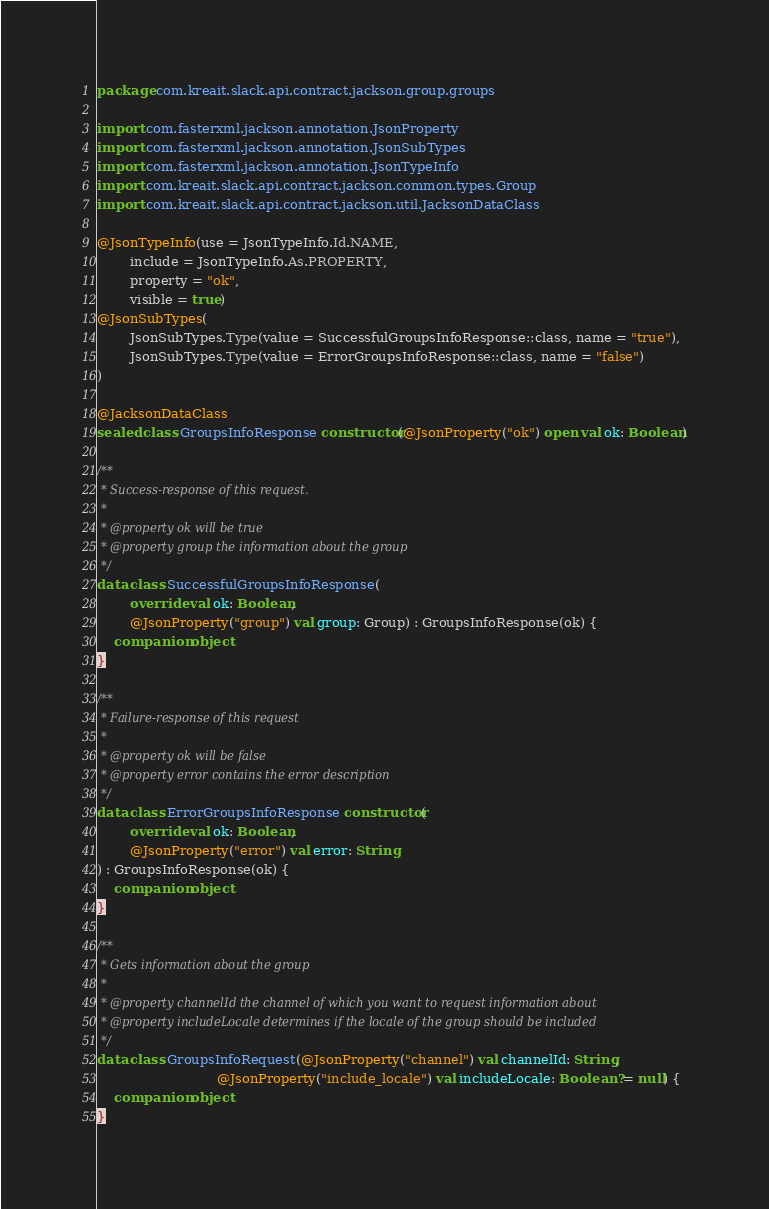<code> <loc_0><loc_0><loc_500><loc_500><_Kotlin_>package com.kreait.slack.api.contract.jackson.group.groups

import com.fasterxml.jackson.annotation.JsonProperty
import com.fasterxml.jackson.annotation.JsonSubTypes
import com.fasterxml.jackson.annotation.JsonTypeInfo
import com.kreait.slack.api.contract.jackson.common.types.Group
import com.kreait.slack.api.contract.jackson.util.JacksonDataClass

@JsonTypeInfo(use = JsonTypeInfo.Id.NAME,
        include = JsonTypeInfo.As.PROPERTY,
        property = "ok",
        visible = true)
@JsonSubTypes(
        JsonSubTypes.Type(value = SuccessfulGroupsInfoResponse::class, name = "true"),
        JsonSubTypes.Type(value = ErrorGroupsInfoResponse::class, name = "false")
)

@JacksonDataClass
sealed class GroupsInfoResponse constructor(@JsonProperty("ok") open val ok: Boolean)

/**
 * Success-response of this request.
 *
 * @property ok will be true
 * @property group the information about the group
 */
data class SuccessfulGroupsInfoResponse(
        override val ok: Boolean,
        @JsonProperty("group") val group: Group) : GroupsInfoResponse(ok) {
    companion object
}

/**
 * Failure-response of this request
 *
 * @property ok will be false
 * @property error contains the error description
 */
data class ErrorGroupsInfoResponse constructor(
        override val ok: Boolean,
        @JsonProperty("error") val error: String
) : GroupsInfoResponse(ok) {
    companion object
}

/**
 * Gets information about the group
 *
 * @property channelId the channel of which you want to request information about
 * @property includeLocale determines if the locale of the group should be included
 */
data class GroupsInfoRequest(@JsonProperty("channel") val channelId: String,
                             @JsonProperty("include_locale") val includeLocale: Boolean? = null) {
    companion object
}
</code> 